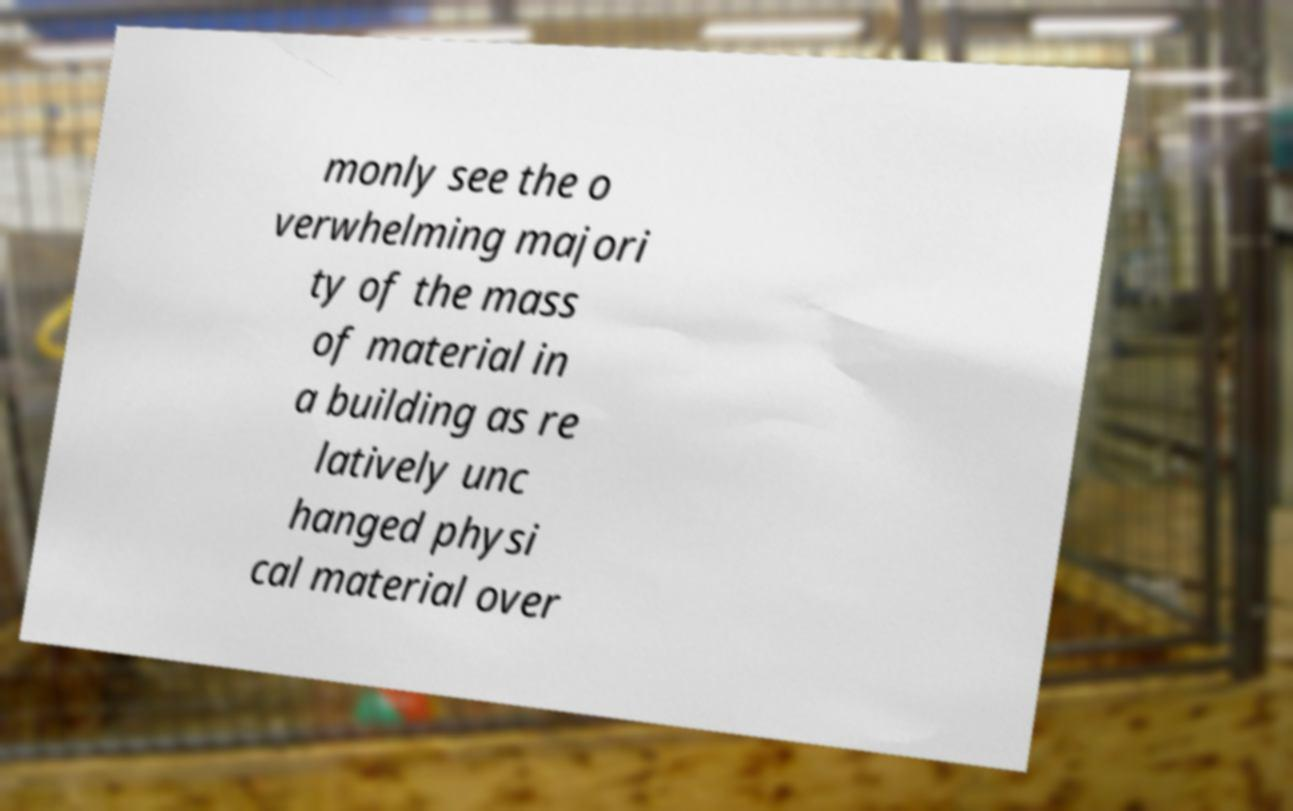What messages or text are displayed in this image? I need them in a readable, typed format. monly see the o verwhelming majori ty of the mass of material in a building as re latively unc hanged physi cal material over 